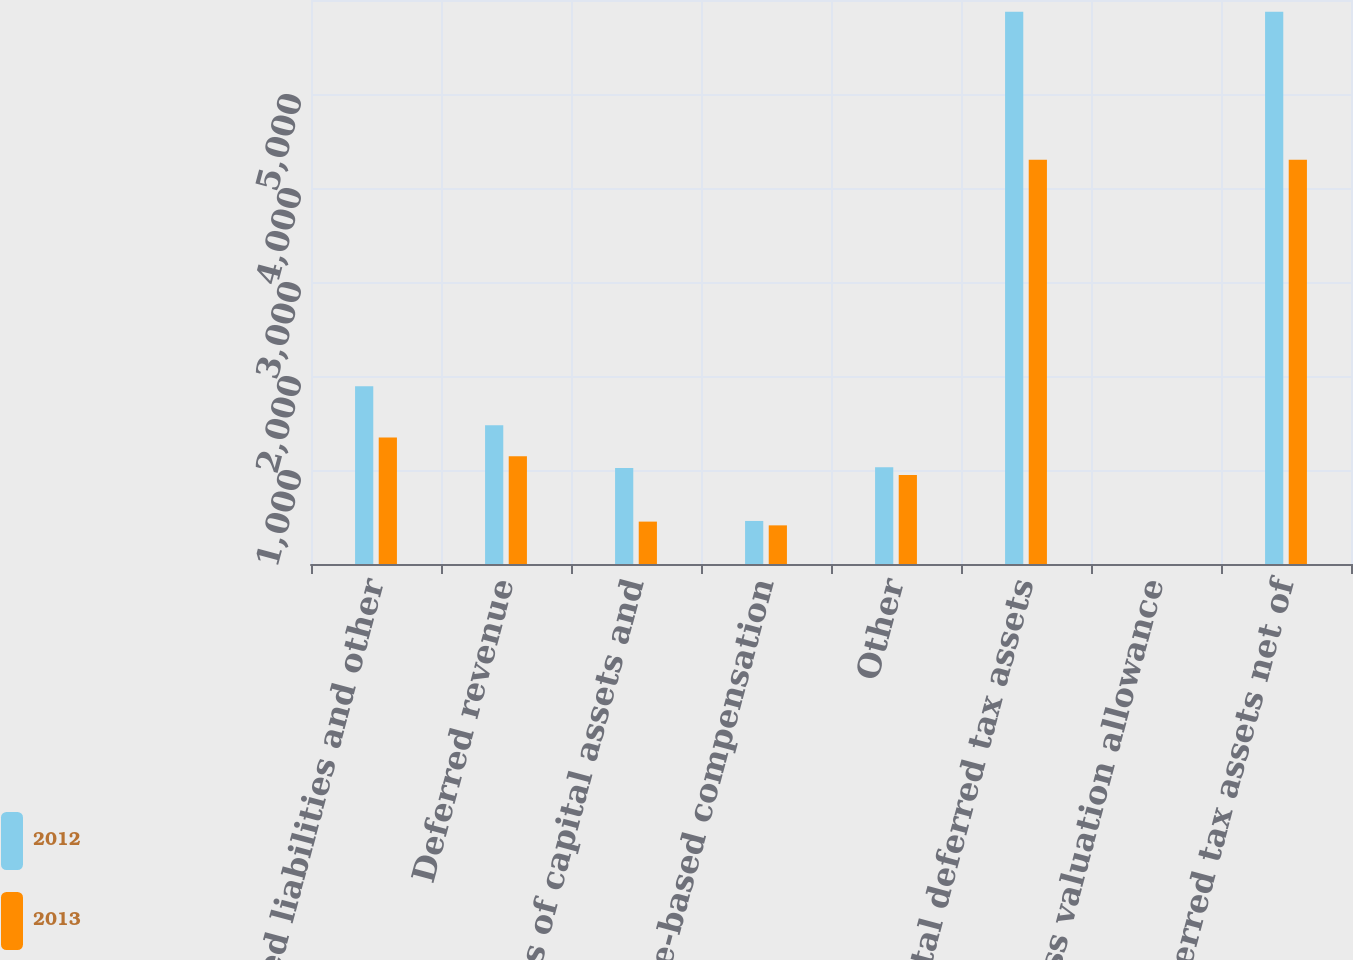<chart> <loc_0><loc_0><loc_500><loc_500><stacked_bar_chart><ecel><fcel>Accrued liabilities and other<fcel>Deferred revenue<fcel>Basis of capital assets and<fcel>Share-based compensation<fcel>Other<fcel>Total deferred tax assets<fcel>Less valuation allowance<fcel>Deferred tax assets net of<nl><fcel>2012<fcel>1892<fcel>1475<fcel>1020<fcel>458<fcel>1029<fcel>5874<fcel>0<fcel>5874<nl><fcel>2013<fcel>1346<fcel>1145<fcel>451<fcel>411<fcel>947<fcel>4300<fcel>0<fcel>4300<nl></chart> 